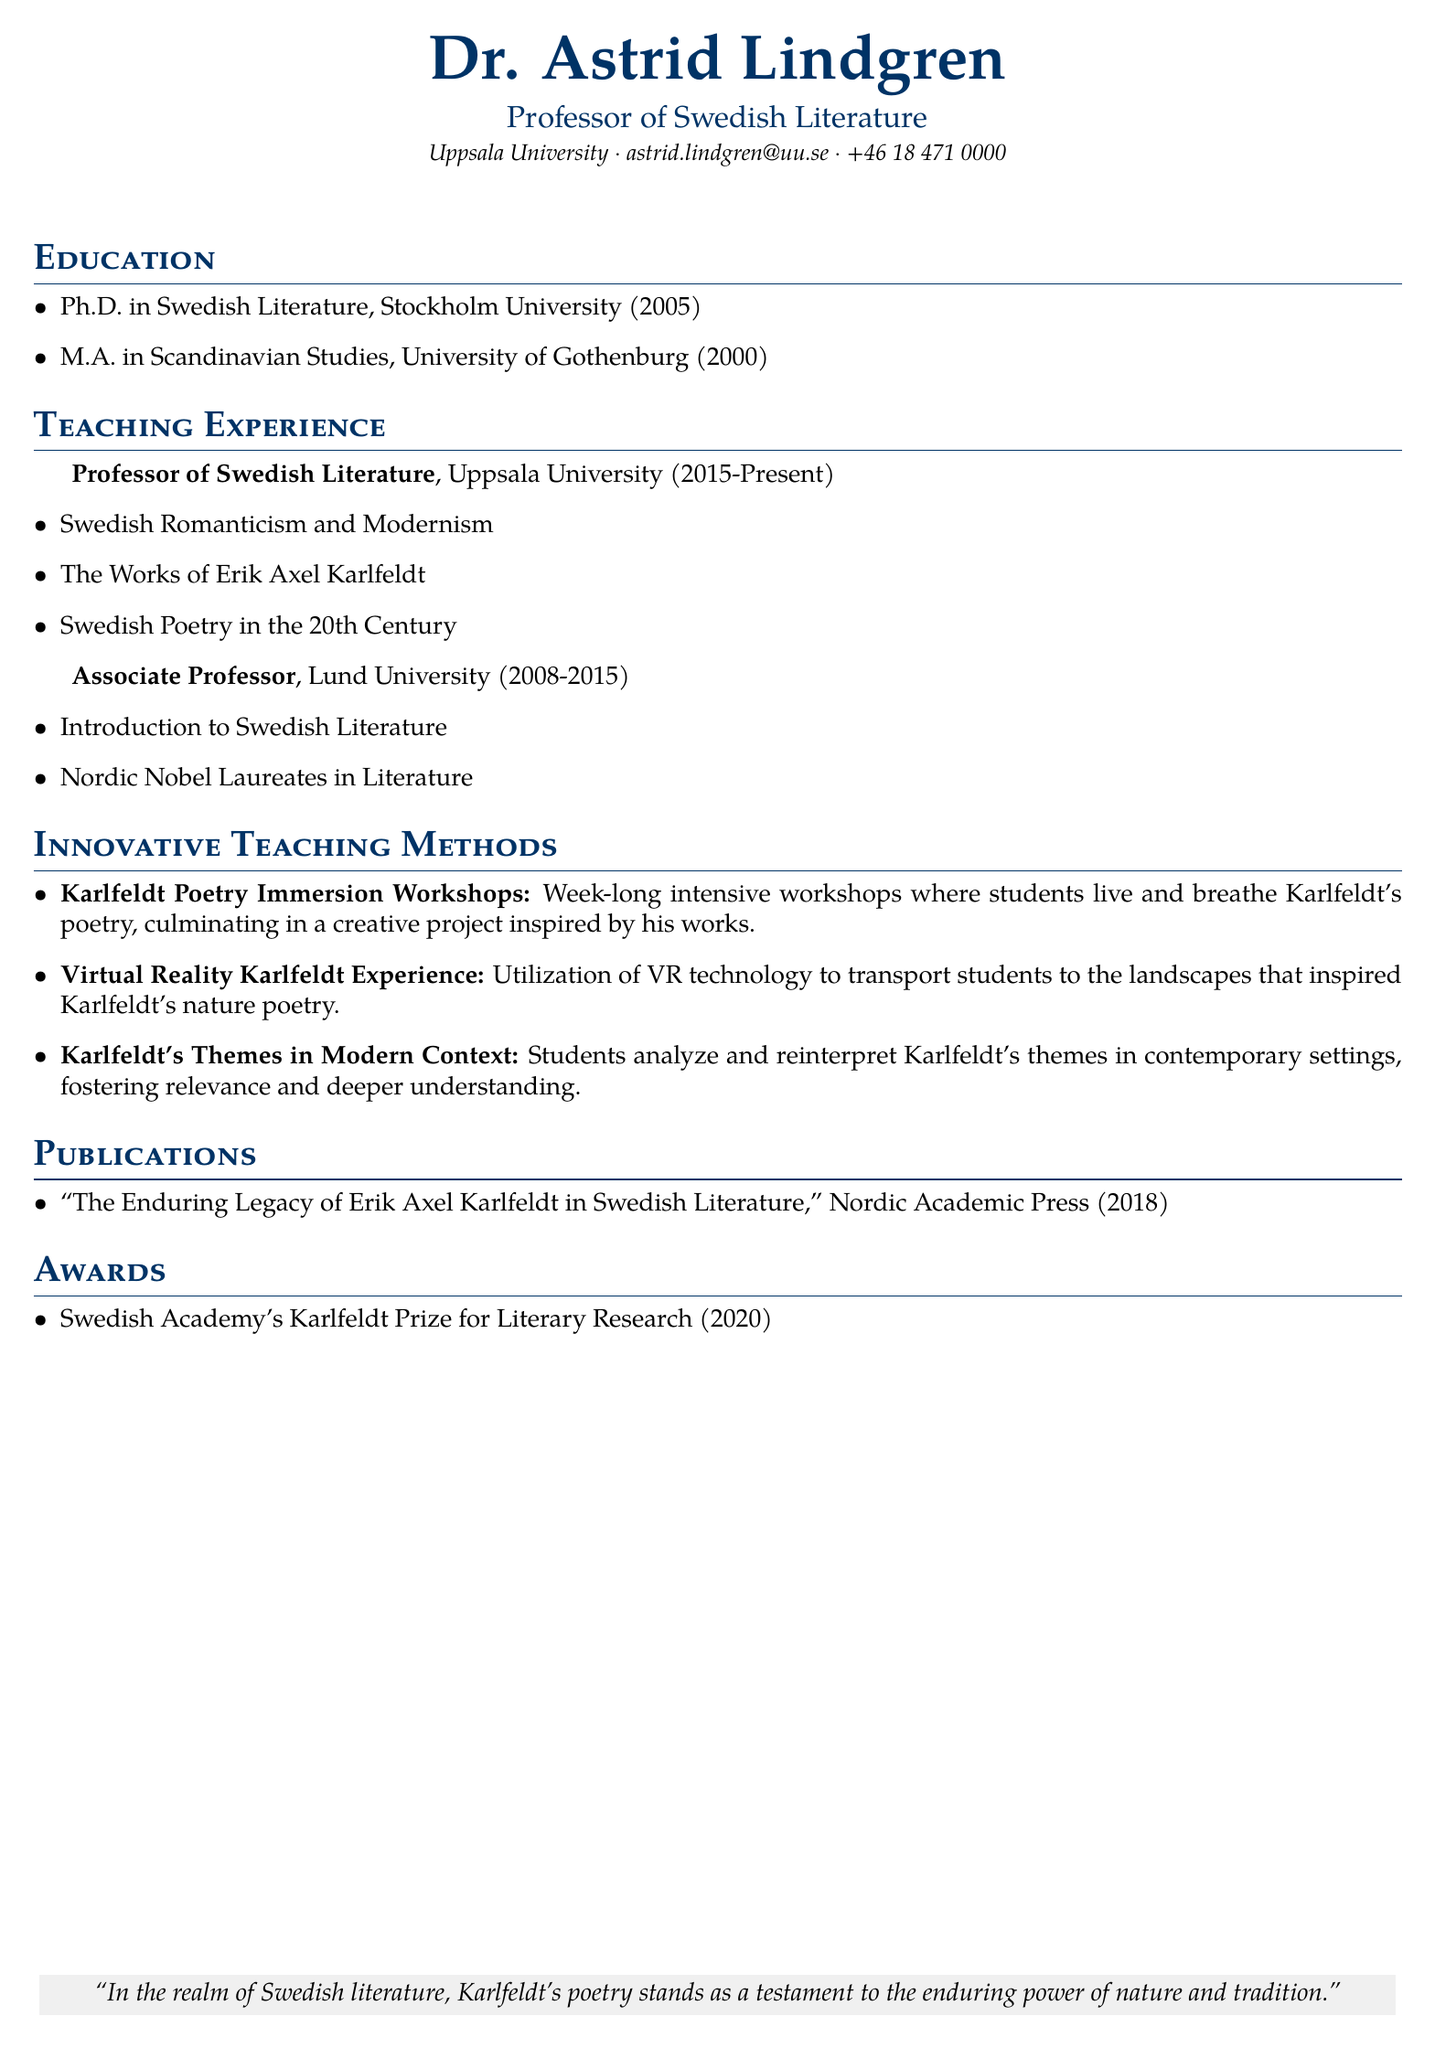what is Dr. Astrid Lindgren's title? Dr. Astrid Lindgren is identified as a Professor of Swedish Literature in the document.
Answer: Professor of Swedish Literature which institution is Dr. Lindgren currently affiliated with? The document states that Dr. Lindgren is affiliated with Uppsala University.
Answer: Uppsala University what year did Dr. Lindgren complete her Ph.D.? According to the document, Dr. Lindgren completed her Ph.D. in 2005.
Answer: 2005 how many courses are listed under Dr. Lindgren's current teaching position? The document lists three courses that Dr. Lindgren teaches as a Professor at Uppsala University.
Answer: three what innovative method uses VR technology? The document describes the "Virtual Reality Karlfeldt Experience" as utilizing VR technology to engage students.
Answer: Virtual Reality Karlfeldt Experience which award did Dr. Lindgren receive in 2020? The document notes that Dr. Lindgren received the Swedish Academy's Karlfeldt Prize for Literary Research in 2020.
Answer: Swedish Academy's Karlfeldt Prize for Literary Research what is the title of Dr. Lindgren's publication? The document states the title of the publication is "The Enduring Legacy of Erik Axel Karlfeldt in Swedish Literature."
Answer: The Enduring Legacy of Erik Axel Karlfeldt in Swedish Literature how long did Dr. Lindgren work at Lund University? According to the document, Dr. Lindgren worked at Lund University from 2008 to 2015, which is a duration of seven years.
Answer: seven years what is the main focus of the "Karlfeldt Poetry Immersion Workshops"? The document specifies that the focus is for students to live and breathe Karlfeldt's poetry during the workshops.
Answer: live and breathe Karlfeldt's poetry 